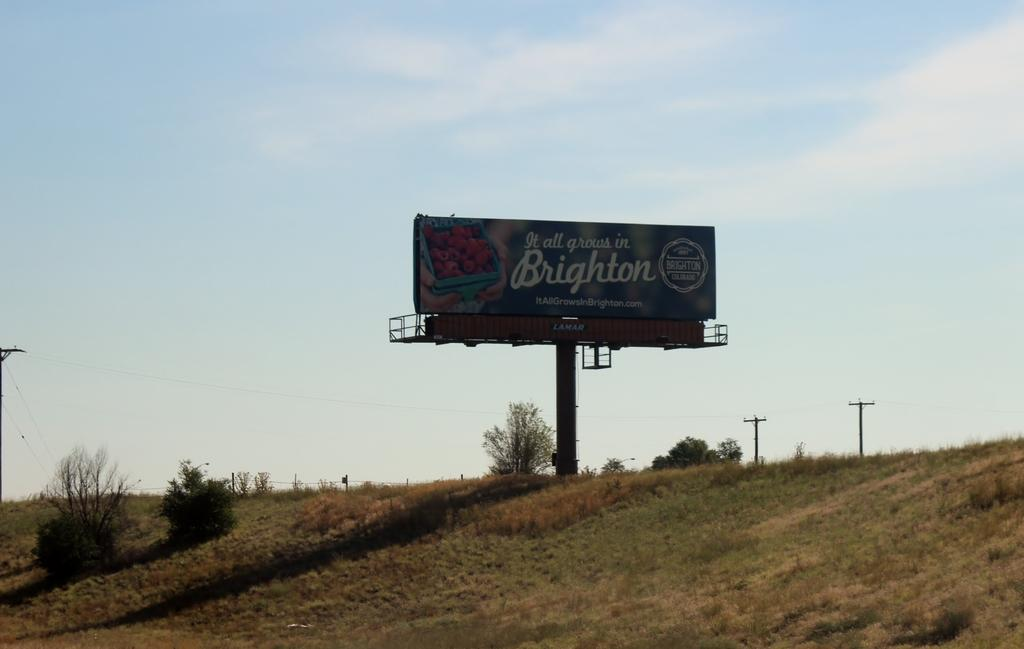What type of vegetation is present in the foreground of the image? There is grass in the foreground of the image, and plants are also present on the slope. What can be seen in the background of the image? In the background, there is a hoarding, poles, trees, and the sky. Can you describe the sky in the image? The sky is visible in the background, and there is a cloud present. How many eyes can be seen on the balloon in the image? There is no balloon present in the image, so it is not possible to determine how many eyes might be on it. 